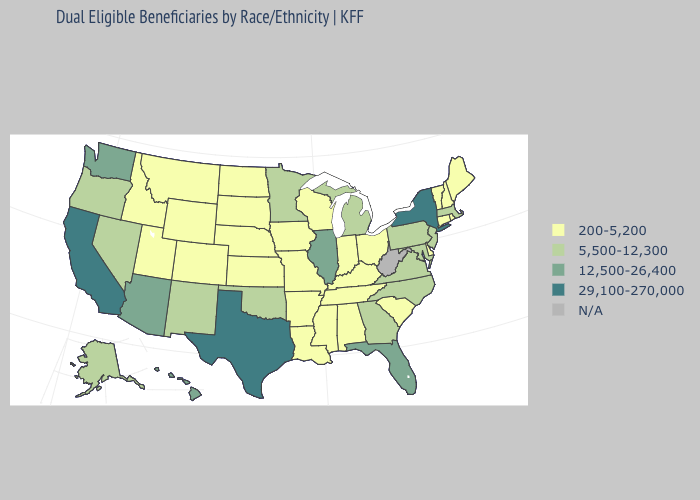What is the value of Nebraska?
Short answer required. 200-5,200. Name the states that have a value in the range N/A?
Answer briefly. West Virginia. What is the value of Mississippi?
Write a very short answer. 200-5,200. Which states hav the highest value in the MidWest?
Concise answer only. Illinois. Name the states that have a value in the range 200-5,200?
Concise answer only. Alabama, Arkansas, Colorado, Connecticut, Delaware, Idaho, Indiana, Iowa, Kansas, Kentucky, Louisiana, Maine, Mississippi, Missouri, Montana, Nebraska, New Hampshire, North Dakota, Ohio, Rhode Island, South Carolina, South Dakota, Tennessee, Utah, Vermont, Wisconsin, Wyoming. What is the lowest value in the Northeast?
Short answer required. 200-5,200. Name the states that have a value in the range N/A?
Answer briefly. West Virginia. Name the states that have a value in the range 200-5,200?
Keep it brief. Alabama, Arkansas, Colorado, Connecticut, Delaware, Idaho, Indiana, Iowa, Kansas, Kentucky, Louisiana, Maine, Mississippi, Missouri, Montana, Nebraska, New Hampshire, North Dakota, Ohio, Rhode Island, South Carolina, South Dakota, Tennessee, Utah, Vermont, Wisconsin, Wyoming. Name the states that have a value in the range 12,500-26,400?
Concise answer only. Arizona, Florida, Hawaii, Illinois, Washington. Name the states that have a value in the range N/A?
Quick response, please. West Virginia. Name the states that have a value in the range 200-5,200?
Give a very brief answer. Alabama, Arkansas, Colorado, Connecticut, Delaware, Idaho, Indiana, Iowa, Kansas, Kentucky, Louisiana, Maine, Mississippi, Missouri, Montana, Nebraska, New Hampshire, North Dakota, Ohio, Rhode Island, South Carolina, South Dakota, Tennessee, Utah, Vermont, Wisconsin, Wyoming. Which states have the lowest value in the USA?
Concise answer only. Alabama, Arkansas, Colorado, Connecticut, Delaware, Idaho, Indiana, Iowa, Kansas, Kentucky, Louisiana, Maine, Mississippi, Missouri, Montana, Nebraska, New Hampshire, North Dakota, Ohio, Rhode Island, South Carolina, South Dakota, Tennessee, Utah, Vermont, Wisconsin, Wyoming. What is the value of Missouri?
Quick response, please. 200-5,200. Does California have the highest value in the USA?
Be succinct. Yes. What is the highest value in the MidWest ?
Quick response, please. 12,500-26,400. 